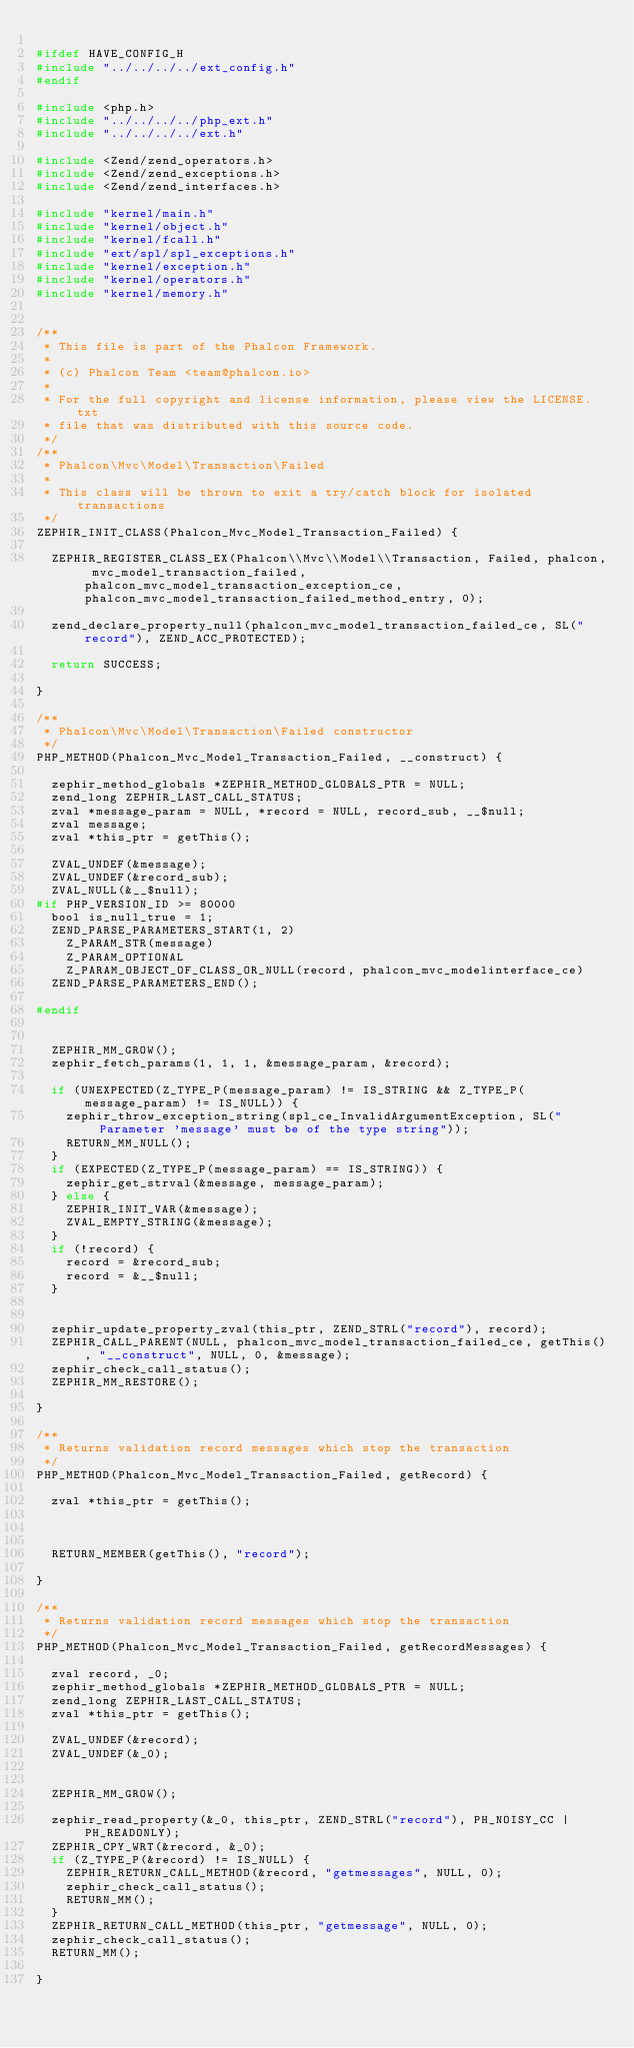<code> <loc_0><loc_0><loc_500><loc_500><_C_>
#ifdef HAVE_CONFIG_H
#include "../../../../ext_config.h"
#endif

#include <php.h>
#include "../../../../php_ext.h"
#include "../../../../ext.h"

#include <Zend/zend_operators.h>
#include <Zend/zend_exceptions.h>
#include <Zend/zend_interfaces.h>

#include "kernel/main.h"
#include "kernel/object.h"
#include "kernel/fcall.h"
#include "ext/spl/spl_exceptions.h"
#include "kernel/exception.h"
#include "kernel/operators.h"
#include "kernel/memory.h"


/**
 * This file is part of the Phalcon Framework.
 *
 * (c) Phalcon Team <team@phalcon.io>
 *
 * For the full copyright and license information, please view the LICENSE.txt
 * file that was distributed with this source code.
 */
/**
 * Phalcon\Mvc\Model\Transaction\Failed
 *
 * This class will be thrown to exit a try/catch block for isolated transactions
 */
ZEPHIR_INIT_CLASS(Phalcon_Mvc_Model_Transaction_Failed) {

	ZEPHIR_REGISTER_CLASS_EX(Phalcon\\Mvc\\Model\\Transaction, Failed, phalcon, mvc_model_transaction_failed, phalcon_mvc_model_transaction_exception_ce, phalcon_mvc_model_transaction_failed_method_entry, 0);

	zend_declare_property_null(phalcon_mvc_model_transaction_failed_ce, SL("record"), ZEND_ACC_PROTECTED);

	return SUCCESS;

}

/**
 * Phalcon\Mvc\Model\Transaction\Failed constructor
 */
PHP_METHOD(Phalcon_Mvc_Model_Transaction_Failed, __construct) {

	zephir_method_globals *ZEPHIR_METHOD_GLOBALS_PTR = NULL;
	zend_long ZEPHIR_LAST_CALL_STATUS;
	zval *message_param = NULL, *record = NULL, record_sub, __$null;
	zval message;
	zval *this_ptr = getThis();

	ZVAL_UNDEF(&message);
	ZVAL_UNDEF(&record_sub);
	ZVAL_NULL(&__$null);
#if PHP_VERSION_ID >= 80000
	bool is_null_true = 1;
	ZEND_PARSE_PARAMETERS_START(1, 2)
		Z_PARAM_STR(message)
		Z_PARAM_OPTIONAL
		Z_PARAM_OBJECT_OF_CLASS_OR_NULL(record, phalcon_mvc_modelinterface_ce)
	ZEND_PARSE_PARAMETERS_END();

#endif


	ZEPHIR_MM_GROW();
	zephir_fetch_params(1, 1, 1, &message_param, &record);

	if (UNEXPECTED(Z_TYPE_P(message_param) != IS_STRING && Z_TYPE_P(message_param) != IS_NULL)) {
		zephir_throw_exception_string(spl_ce_InvalidArgumentException, SL("Parameter 'message' must be of the type string"));
		RETURN_MM_NULL();
	}
	if (EXPECTED(Z_TYPE_P(message_param) == IS_STRING)) {
		zephir_get_strval(&message, message_param);
	} else {
		ZEPHIR_INIT_VAR(&message);
		ZVAL_EMPTY_STRING(&message);
	}
	if (!record) {
		record = &record_sub;
		record = &__$null;
	}


	zephir_update_property_zval(this_ptr, ZEND_STRL("record"), record);
	ZEPHIR_CALL_PARENT(NULL, phalcon_mvc_model_transaction_failed_ce, getThis(), "__construct", NULL, 0, &message);
	zephir_check_call_status();
	ZEPHIR_MM_RESTORE();

}

/**
 * Returns validation record messages which stop the transaction
 */
PHP_METHOD(Phalcon_Mvc_Model_Transaction_Failed, getRecord) {

	zval *this_ptr = getThis();



	RETURN_MEMBER(getThis(), "record");

}

/**
 * Returns validation record messages which stop the transaction
 */
PHP_METHOD(Phalcon_Mvc_Model_Transaction_Failed, getRecordMessages) {

	zval record, _0;
	zephir_method_globals *ZEPHIR_METHOD_GLOBALS_PTR = NULL;
	zend_long ZEPHIR_LAST_CALL_STATUS;
	zval *this_ptr = getThis();

	ZVAL_UNDEF(&record);
	ZVAL_UNDEF(&_0);


	ZEPHIR_MM_GROW();

	zephir_read_property(&_0, this_ptr, ZEND_STRL("record"), PH_NOISY_CC | PH_READONLY);
	ZEPHIR_CPY_WRT(&record, &_0);
	if (Z_TYPE_P(&record) != IS_NULL) {
		ZEPHIR_RETURN_CALL_METHOD(&record, "getmessages", NULL, 0);
		zephir_check_call_status();
		RETURN_MM();
	}
	ZEPHIR_RETURN_CALL_METHOD(this_ptr, "getmessage", NULL, 0);
	zephir_check_call_status();
	RETURN_MM();

}

</code> 